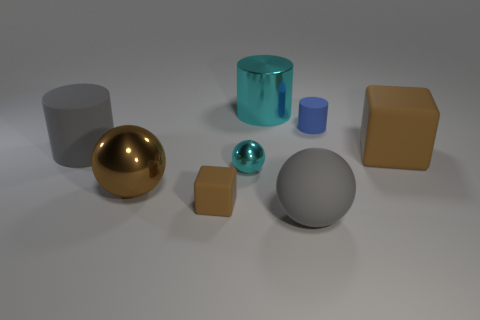There is a rubber thing that is the same color as the rubber sphere; what is its size?
Offer a terse response. Large. There is a matte object that is the same color as the small rubber block; what is its shape?
Make the answer very short. Cube. Is there a big cyan thing made of the same material as the big brown sphere?
Make the answer very short. Yes. The metallic cylinder is what size?
Your response must be concise. Large. How many green things are large shiny cylinders or tiny cylinders?
Provide a short and direct response. 0. What number of large brown rubber things are the same shape as the tiny brown object?
Provide a succinct answer. 1. How many brown matte cubes have the same size as the brown ball?
Keep it short and to the point. 1. There is a big gray object that is the same shape as the big cyan shiny object; what material is it?
Provide a succinct answer. Rubber. What color is the large ball that is to the left of the big gray matte sphere?
Ensure brevity in your answer.  Brown. Is the number of brown rubber blocks right of the cyan ball greater than the number of large matte cylinders?
Offer a very short reply. No. 